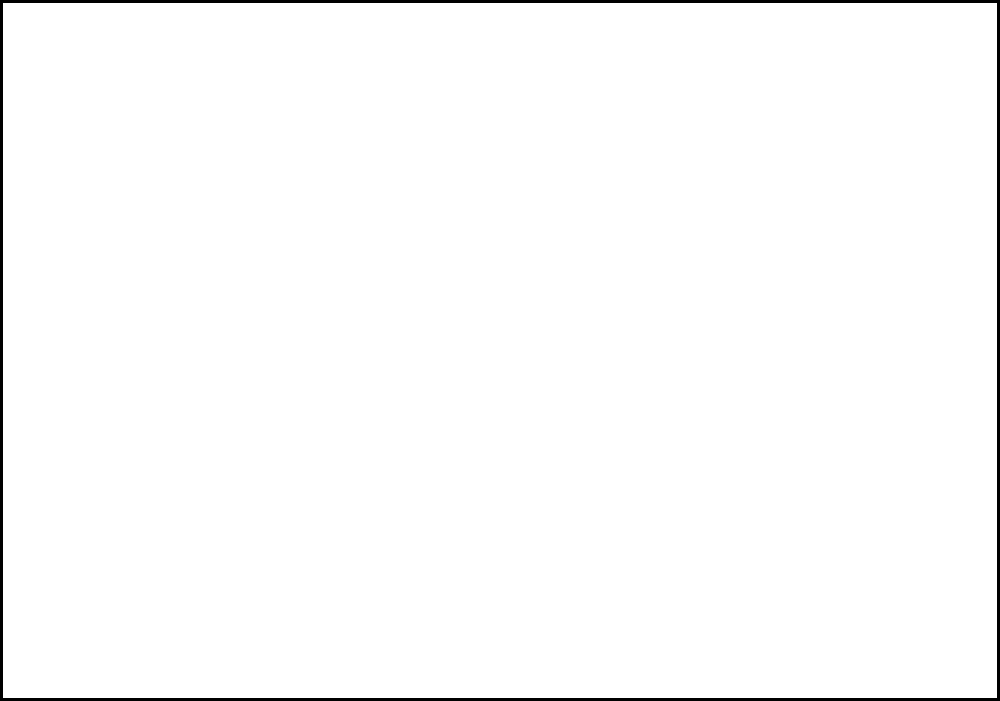Based on the heat map of a forward's movement during a match, which area of the pitch did the player spend the most time in, and what tactical role might this suggest? To interpret this heat map and determine the player's most frequent position and tactical role, let's follow these steps:

1. Understand the heat map: 
   - The darker red areas indicate higher presence/activity.
   - The lighter red or white areas indicate lower presence/activity.

2. Identify the area with the darkest red:
   - The center of the pitch, slightly towards the left, shows the most intense red color.

3. Correlate the position with tactical roles:
   - The central area is typically associated with a center forward or a "false 9" role.
   - The slight bias to the left suggests the player might also drift to the left wing occasionally.

4. Consider the spread of activity:
   - There's significant activity across the front line, indicating the player is mobile.
   - Less activity is seen in deep positions, suggesting the player doesn't often drop back.

5. Tactical implications:
   - The player seems to be a central striker who prefers to play slightly to the left.
   - They likely act as the focal point of attacks, holding up play and linking with teammates.
   - The mobility across the front line suggests they're involved in fluid attacking movements.

Given this analysis, the player appears to be operating primarily as a center forward with a tendency to drift left, possibly in a "false 9" or modern striker role that combines holding up play with creating chances for teammates.
Answer: Center-left forward; likely a mobile striker or "false 9" role 